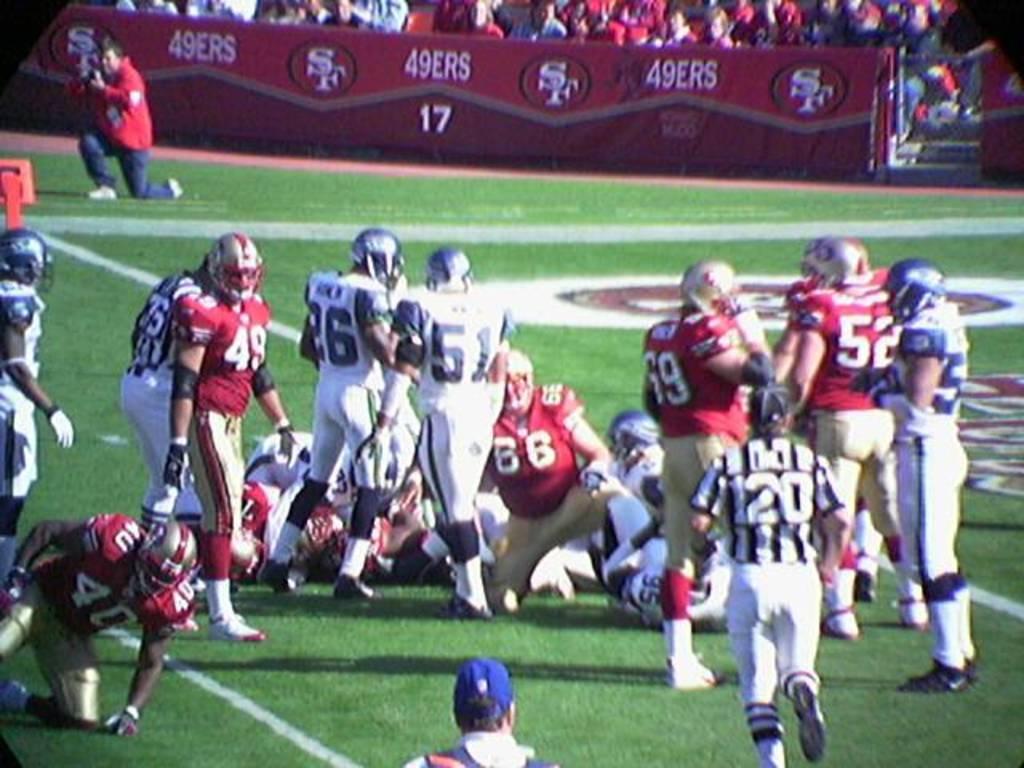Please provide a concise description of this image. In this image we can see people standing and sitting on the ground. In the background there are advertisement boards and spectators. 